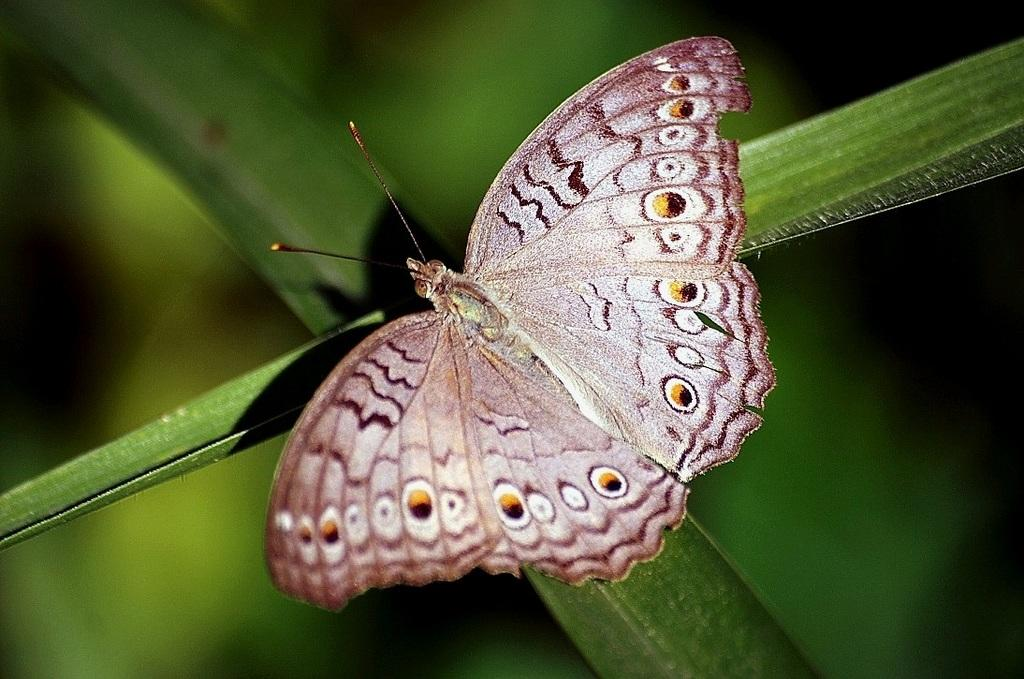What is the main subject of the image? The main subject of the image is a butterfly. Where is the butterfly located in the image? The butterfly is on a greenery object. What is the background of the image? The background of the image is greenery. What type of nerve can be seen in the image? There is no nerve present in the image; it features a butterfly on a greenery object. What type of spot is visible on the butterfly in the image? There is no specific spot mentioned in the facts provided, but the butterfly may have various spots or patterns on its wings. 